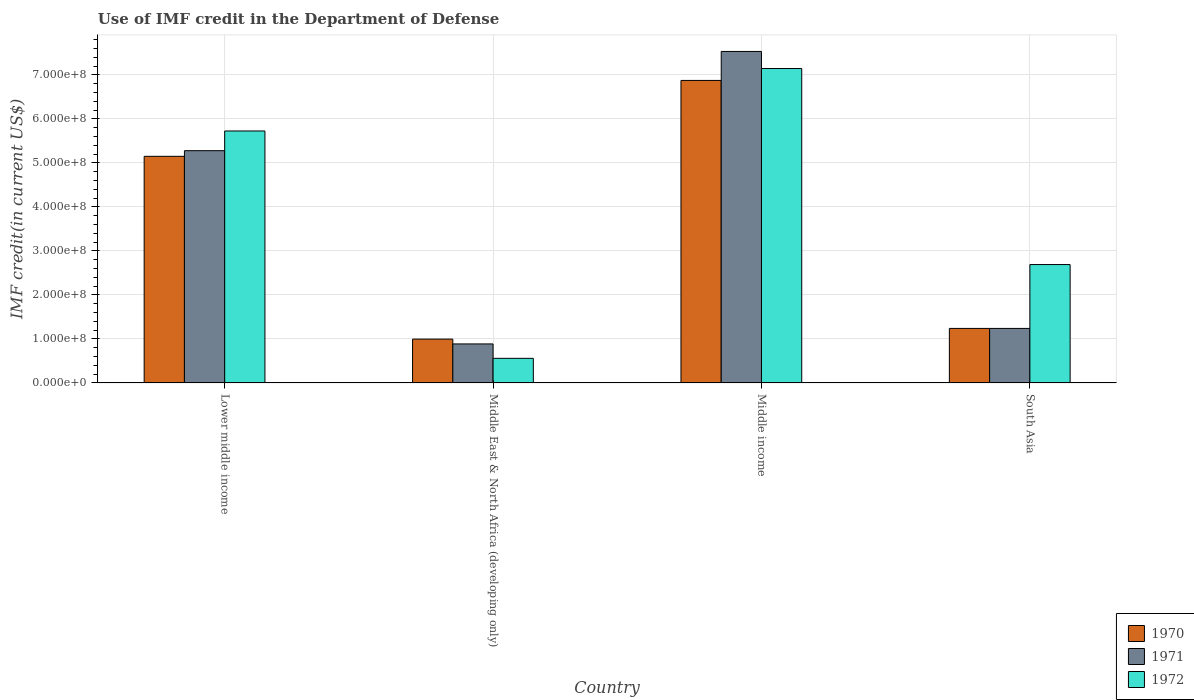How many groups of bars are there?
Offer a terse response. 4. Are the number of bars on each tick of the X-axis equal?
Keep it short and to the point. Yes. In how many cases, is the number of bars for a given country not equal to the number of legend labels?
Give a very brief answer. 0. What is the IMF credit in the Department of Defense in 1970 in Middle income?
Give a very brief answer. 6.87e+08. Across all countries, what is the maximum IMF credit in the Department of Defense in 1970?
Your response must be concise. 6.87e+08. Across all countries, what is the minimum IMF credit in the Department of Defense in 1970?
Make the answer very short. 9.96e+07. In which country was the IMF credit in the Department of Defense in 1972 minimum?
Your answer should be compact. Middle East & North Africa (developing only). What is the total IMF credit in the Department of Defense in 1972 in the graph?
Offer a very short reply. 1.61e+09. What is the difference between the IMF credit in the Department of Defense in 1970 in Middle East & North Africa (developing only) and that in South Asia?
Your response must be concise. -2.43e+07. What is the difference between the IMF credit in the Department of Defense in 1972 in Middle income and the IMF credit in the Department of Defense in 1970 in South Asia?
Your response must be concise. 5.91e+08. What is the average IMF credit in the Department of Defense in 1972 per country?
Provide a short and direct response. 4.03e+08. What is the difference between the IMF credit in the Department of Defense of/in 1971 and IMF credit in the Department of Defense of/in 1970 in Middle East & North Africa (developing only)?
Your answer should be very brief. -1.10e+07. In how many countries, is the IMF credit in the Department of Defense in 1972 greater than 180000000 US$?
Offer a terse response. 3. What is the ratio of the IMF credit in the Department of Defense in 1972 in Middle East & North Africa (developing only) to that in South Asia?
Provide a short and direct response. 0.21. Is the IMF credit in the Department of Defense in 1972 in Middle East & North Africa (developing only) less than that in Middle income?
Provide a short and direct response. Yes. What is the difference between the highest and the second highest IMF credit in the Department of Defense in 1972?
Ensure brevity in your answer.  -4.45e+08. What is the difference between the highest and the lowest IMF credit in the Department of Defense in 1970?
Provide a short and direct response. 5.88e+08. In how many countries, is the IMF credit in the Department of Defense in 1971 greater than the average IMF credit in the Department of Defense in 1971 taken over all countries?
Your response must be concise. 2. What does the 3rd bar from the left in Middle East & North Africa (developing only) represents?
Provide a short and direct response. 1972. Is it the case that in every country, the sum of the IMF credit in the Department of Defense in 1972 and IMF credit in the Department of Defense in 1971 is greater than the IMF credit in the Department of Defense in 1970?
Your response must be concise. Yes. How many bars are there?
Your answer should be compact. 12. Are all the bars in the graph horizontal?
Your answer should be very brief. No. What is the difference between two consecutive major ticks on the Y-axis?
Offer a terse response. 1.00e+08. Does the graph contain grids?
Give a very brief answer. Yes. How many legend labels are there?
Your response must be concise. 3. What is the title of the graph?
Keep it short and to the point. Use of IMF credit in the Department of Defense. What is the label or title of the Y-axis?
Provide a short and direct response. IMF credit(in current US$). What is the IMF credit(in current US$) of 1970 in Lower middle income?
Keep it short and to the point. 5.15e+08. What is the IMF credit(in current US$) of 1971 in Lower middle income?
Your answer should be very brief. 5.28e+08. What is the IMF credit(in current US$) of 1972 in Lower middle income?
Your answer should be very brief. 5.73e+08. What is the IMF credit(in current US$) in 1970 in Middle East & North Africa (developing only)?
Provide a short and direct response. 9.96e+07. What is the IMF credit(in current US$) of 1971 in Middle East & North Africa (developing only)?
Offer a very short reply. 8.86e+07. What is the IMF credit(in current US$) of 1972 in Middle East & North Africa (developing only)?
Your answer should be very brief. 5.59e+07. What is the IMF credit(in current US$) of 1970 in Middle income?
Offer a very short reply. 6.87e+08. What is the IMF credit(in current US$) of 1971 in Middle income?
Offer a terse response. 7.53e+08. What is the IMF credit(in current US$) in 1972 in Middle income?
Your answer should be very brief. 7.14e+08. What is the IMF credit(in current US$) of 1970 in South Asia?
Make the answer very short. 1.24e+08. What is the IMF credit(in current US$) of 1971 in South Asia?
Offer a very short reply. 1.24e+08. What is the IMF credit(in current US$) in 1972 in South Asia?
Ensure brevity in your answer.  2.69e+08. Across all countries, what is the maximum IMF credit(in current US$) of 1970?
Provide a succinct answer. 6.87e+08. Across all countries, what is the maximum IMF credit(in current US$) in 1971?
Provide a short and direct response. 7.53e+08. Across all countries, what is the maximum IMF credit(in current US$) in 1972?
Keep it short and to the point. 7.14e+08. Across all countries, what is the minimum IMF credit(in current US$) in 1970?
Provide a succinct answer. 9.96e+07. Across all countries, what is the minimum IMF credit(in current US$) of 1971?
Your response must be concise. 8.86e+07. Across all countries, what is the minimum IMF credit(in current US$) of 1972?
Keep it short and to the point. 5.59e+07. What is the total IMF credit(in current US$) in 1970 in the graph?
Give a very brief answer. 1.43e+09. What is the total IMF credit(in current US$) of 1971 in the graph?
Provide a succinct answer. 1.49e+09. What is the total IMF credit(in current US$) of 1972 in the graph?
Make the answer very short. 1.61e+09. What is the difference between the IMF credit(in current US$) in 1970 in Lower middle income and that in Middle East & North Africa (developing only)?
Your answer should be very brief. 4.15e+08. What is the difference between the IMF credit(in current US$) in 1971 in Lower middle income and that in Middle East & North Africa (developing only)?
Make the answer very short. 4.39e+08. What is the difference between the IMF credit(in current US$) of 1972 in Lower middle income and that in Middle East & North Africa (developing only)?
Your response must be concise. 5.17e+08. What is the difference between the IMF credit(in current US$) of 1970 in Lower middle income and that in Middle income?
Your response must be concise. -1.72e+08. What is the difference between the IMF credit(in current US$) of 1971 in Lower middle income and that in Middle income?
Your answer should be compact. -2.25e+08. What is the difference between the IMF credit(in current US$) in 1972 in Lower middle income and that in Middle income?
Provide a short and direct response. -1.42e+08. What is the difference between the IMF credit(in current US$) in 1970 in Lower middle income and that in South Asia?
Your response must be concise. 3.91e+08. What is the difference between the IMF credit(in current US$) of 1971 in Lower middle income and that in South Asia?
Ensure brevity in your answer.  4.04e+08. What is the difference between the IMF credit(in current US$) of 1972 in Lower middle income and that in South Asia?
Give a very brief answer. 3.04e+08. What is the difference between the IMF credit(in current US$) of 1970 in Middle East & North Africa (developing only) and that in Middle income?
Your answer should be very brief. -5.88e+08. What is the difference between the IMF credit(in current US$) in 1971 in Middle East & North Africa (developing only) and that in Middle income?
Your answer should be compact. -6.65e+08. What is the difference between the IMF credit(in current US$) of 1972 in Middle East & North Africa (developing only) and that in Middle income?
Your answer should be compact. -6.59e+08. What is the difference between the IMF credit(in current US$) in 1970 in Middle East & North Africa (developing only) and that in South Asia?
Ensure brevity in your answer.  -2.43e+07. What is the difference between the IMF credit(in current US$) in 1971 in Middle East & North Africa (developing only) and that in South Asia?
Offer a terse response. -3.53e+07. What is the difference between the IMF credit(in current US$) in 1972 in Middle East & North Africa (developing only) and that in South Asia?
Your answer should be compact. -2.13e+08. What is the difference between the IMF credit(in current US$) of 1970 in Middle income and that in South Asia?
Offer a terse response. 5.64e+08. What is the difference between the IMF credit(in current US$) in 1971 in Middle income and that in South Asia?
Offer a terse response. 6.29e+08. What is the difference between the IMF credit(in current US$) of 1972 in Middle income and that in South Asia?
Your answer should be very brief. 4.45e+08. What is the difference between the IMF credit(in current US$) of 1970 in Lower middle income and the IMF credit(in current US$) of 1971 in Middle East & North Africa (developing only)?
Your answer should be very brief. 4.26e+08. What is the difference between the IMF credit(in current US$) in 1970 in Lower middle income and the IMF credit(in current US$) in 1972 in Middle East & North Africa (developing only)?
Make the answer very short. 4.59e+08. What is the difference between the IMF credit(in current US$) of 1971 in Lower middle income and the IMF credit(in current US$) of 1972 in Middle East & North Africa (developing only)?
Your answer should be very brief. 4.72e+08. What is the difference between the IMF credit(in current US$) in 1970 in Lower middle income and the IMF credit(in current US$) in 1971 in Middle income?
Keep it short and to the point. -2.38e+08. What is the difference between the IMF credit(in current US$) in 1970 in Lower middle income and the IMF credit(in current US$) in 1972 in Middle income?
Make the answer very short. -2.00e+08. What is the difference between the IMF credit(in current US$) in 1971 in Lower middle income and the IMF credit(in current US$) in 1972 in Middle income?
Ensure brevity in your answer.  -1.87e+08. What is the difference between the IMF credit(in current US$) in 1970 in Lower middle income and the IMF credit(in current US$) in 1971 in South Asia?
Give a very brief answer. 3.91e+08. What is the difference between the IMF credit(in current US$) of 1970 in Lower middle income and the IMF credit(in current US$) of 1972 in South Asia?
Ensure brevity in your answer.  2.46e+08. What is the difference between the IMF credit(in current US$) in 1971 in Lower middle income and the IMF credit(in current US$) in 1972 in South Asia?
Your answer should be very brief. 2.59e+08. What is the difference between the IMF credit(in current US$) in 1970 in Middle East & North Africa (developing only) and the IMF credit(in current US$) in 1971 in Middle income?
Give a very brief answer. -6.54e+08. What is the difference between the IMF credit(in current US$) of 1970 in Middle East & North Africa (developing only) and the IMF credit(in current US$) of 1972 in Middle income?
Give a very brief answer. -6.15e+08. What is the difference between the IMF credit(in current US$) in 1971 in Middle East & North Africa (developing only) and the IMF credit(in current US$) in 1972 in Middle income?
Provide a succinct answer. -6.26e+08. What is the difference between the IMF credit(in current US$) of 1970 in Middle East & North Africa (developing only) and the IMF credit(in current US$) of 1971 in South Asia?
Offer a terse response. -2.43e+07. What is the difference between the IMF credit(in current US$) in 1970 in Middle East & North Africa (developing only) and the IMF credit(in current US$) in 1972 in South Asia?
Your answer should be very brief. -1.69e+08. What is the difference between the IMF credit(in current US$) in 1971 in Middle East & North Africa (developing only) and the IMF credit(in current US$) in 1972 in South Asia?
Ensure brevity in your answer.  -1.80e+08. What is the difference between the IMF credit(in current US$) of 1970 in Middle income and the IMF credit(in current US$) of 1971 in South Asia?
Ensure brevity in your answer.  5.64e+08. What is the difference between the IMF credit(in current US$) of 1970 in Middle income and the IMF credit(in current US$) of 1972 in South Asia?
Keep it short and to the point. 4.18e+08. What is the difference between the IMF credit(in current US$) in 1971 in Middle income and the IMF credit(in current US$) in 1972 in South Asia?
Provide a short and direct response. 4.84e+08. What is the average IMF credit(in current US$) of 1970 per country?
Make the answer very short. 3.56e+08. What is the average IMF credit(in current US$) of 1971 per country?
Give a very brief answer. 3.73e+08. What is the average IMF credit(in current US$) of 1972 per country?
Provide a succinct answer. 4.03e+08. What is the difference between the IMF credit(in current US$) in 1970 and IMF credit(in current US$) in 1971 in Lower middle income?
Offer a very short reply. -1.28e+07. What is the difference between the IMF credit(in current US$) in 1970 and IMF credit(in current US$) in 1972 in Lower middle income?
Provide a short and direct response. -5.76e+07. What is the difference between the IMF credit(in current US$) in 1971 and IMF credit(in current US$) in 1972 in Lower middle income?
Make the answer very short. -4.48e+07. What is the difference between the IMF credit(in current US$) in 1970 and IMF credit(in current US$) in 1971 in Middle East & North Africa (developing only)?
Provide a short and direct response. 1.10e+07. What is the difference between the IMF credit(in current US$) in 1970 and IMF credit(in current US$) in 1972 in Middle East & North Africa (developing only)?
Make the answer very short. 4.37e+07. What is the difference between the IMF credit(in current US$) of 1971 and IMF credit(in current US$) of 1972 in Middle East & North Africa (developing only)?
Ensure brevity in your answer.  3.27e+07. What is the difference between the IMF credit(in current US$) of 1970 and IMF credit(in current US$) of 1971 in Middle income?
Provide a succinct answer. -6.58e+07. What is the difference between the IMF credit(in current US$) of 1970 and IMF credit(in current US$) of 1972 in Middle income?
Ensure brevity in your answer.  -2.71e+07. What is the difference between the IMF credit(in current US$) in 1971 and IMF credit(in current US$) in 1972 in Middle income?
Your answer should be compact. 3.88e+07. What is the difference between the IMF credit(in current US$) in 1970 and IMF credit(in current US$) in 1972 in South Asia?
Provide a succinct answer. -1.45e+08. What is the difference between the IMF credit(in current US$) of 1971 and IMF credit(in current US$) of 1972 in South Asia?
Give a very brief answer. -1.45e+08. What is the ratio of the IMF credit(in current US$) in 1970 in Lower middle income to that in Middle East & North Africa (developing only)?
Make the answer very short. 5.17. What is the ratio of the IMF credit(in current US$) in 1971 in Lower middle income to that in Middle East & North Africa (developing only)?
Ensure brevity in your answer.  5.95. What is the ratio of the IMF credit(in current US$) of 1972 in Lower middle income to that in Middle East & North Africa (developing only)?
Make the answer very short. 10.24. What is the ratio of the IMF credit(in current US$) of 1970 in Lower middle income to that in Middle income?
Your answer should be very brief. 0.75. What is the ratio of the IMF credit(in current US$) of 1971 in Lower middle income to that in Middle income?
Give a very brief answer. 0.7. What is the ratio of the IMF credit(in current US$) of 1972 in Lower middle income to that in Middle income?
Offer a terse response. 0.8. What is the ratio of the IMF credit(in current US$) in 1970 in Lower middle income to that in South Asia?
Give a very brief answer. 4.16. What is the ratio of the IMF credit(in current US$) of 1971 in Lower middle income to that in South Asia?
Ensure brevity in your answer.  4.26. What is the ratio of the IMF credit(in current US$) of 1972 in Lower middle income to that in South Asia?
Offer a very short reply. 2.13. What is the ratio of the IMF credit(in current US$) in 1970 in Middle East & North Africa (developing only) to that in Middle income?
Ensure brevity in your answer.  0.14. What is the ratio of the IMF credit(in current US$) of 1971 in Middle East & North Africa (developing only) to that in Middle income?
Your answer should be very brief. 0.12. What is the ratio of the IMF credit(in current US$) of 1972 in Middle East & North Africa (developing only) to that in Middle income?
Provide a succinct answer. 0.08. What is the ratio of the IMF credit(in current US$) in 1970 in Middle East & North Africa (developing only) to that in South Asia?
Keep it short and to the point. 0.8. What is the ratio of the IMF credit(in current US$) of 1971 in Middle East & North Africa (developing only) to that in South Asia?
Your response must be concise. 0.72. What is the ratio of the IMF credit(in current US$) of 1972 in Middle East & North Africa (developing only) to that in South Asia?
Keep it short and to the point. 0.21. What is the ratio of the IMF credit(in current US$) of 1970 in Middle income to that in South Asia?
Provide a succinct answer. 5.55. What is the ratio of the IMF credit(in current US$) of 1971 in Middle income to that in South Asia?
Your response must be concise. 6.08. What is the ratio of the IMF credit(in current US$) in 1972 in Middle income to that in South Asia?
Make the answer very short. 2.66. What is the difference between the highest and the second highest IMF credit(in current US$) in 1970?
Give a very brief answer. 1.72e+08. What is the difference between the highest and the second highest IMF credit(in current US$) in 1971?
Give a very brief answer. 2.25e+08. What is the difference between the highest and the second highest IMF credit(in current US$) of 1972?
Ensure brevity in your answer.  1.42e+08. What is the difference between the highest and the lowest IMF credit(in current US$) of 1970?
Ensure brevity in your answer.  5.88e+08. What is the difference between the highest and the lowest IMF credit(in current US$) in 1971?
Your answer should be very brief. 6.65e+08. What is the difference between the highest and the lowest IMF credit(in current US$) of 1972?
Your answer should be very brief. 6.59e+08. 